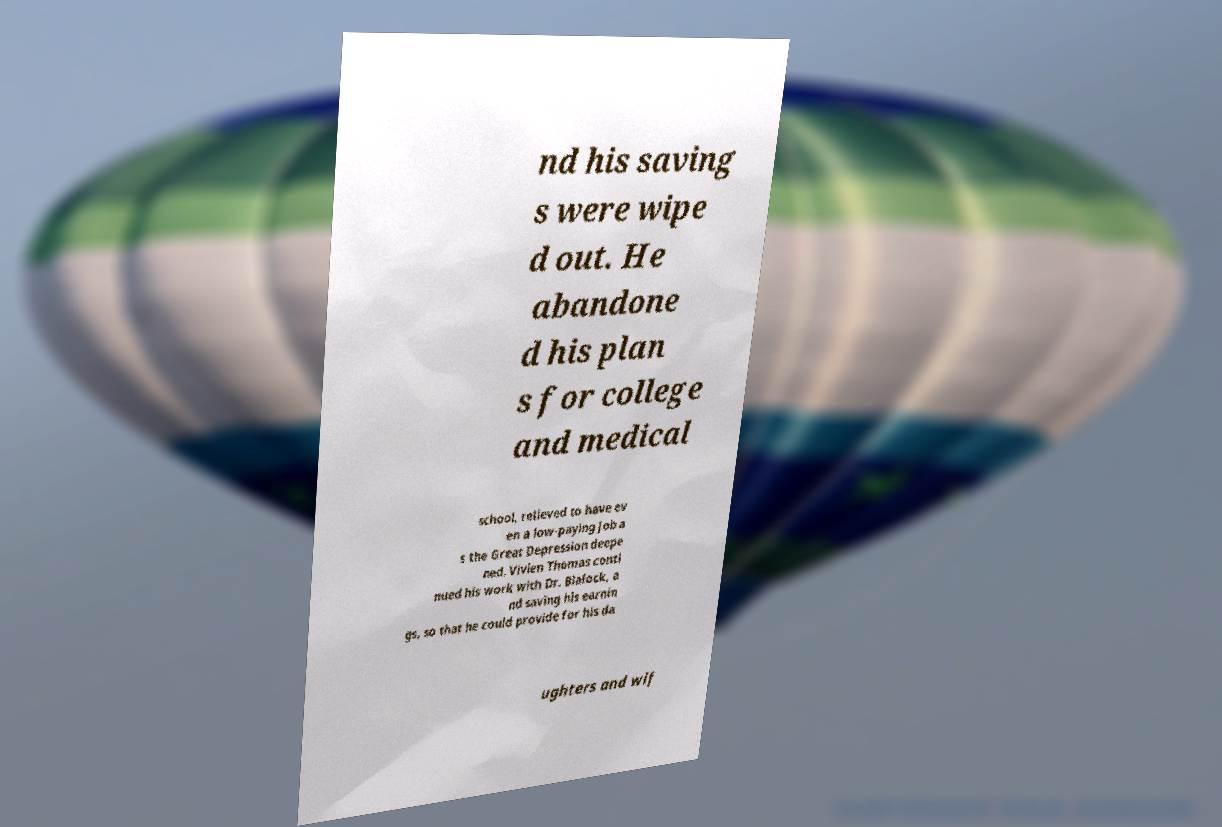Could you extract and type out the text from this image? nd his saving s were wipe d out. He abandone d his plan s for college and medical school, relieved to have ev en a low-paying job a s the Great Depression deepe ned. Vivien Thomas conti nued his work with Dr. Blalock, a nd saving his earnin gs, so that he could provide for his da ughters and wif 